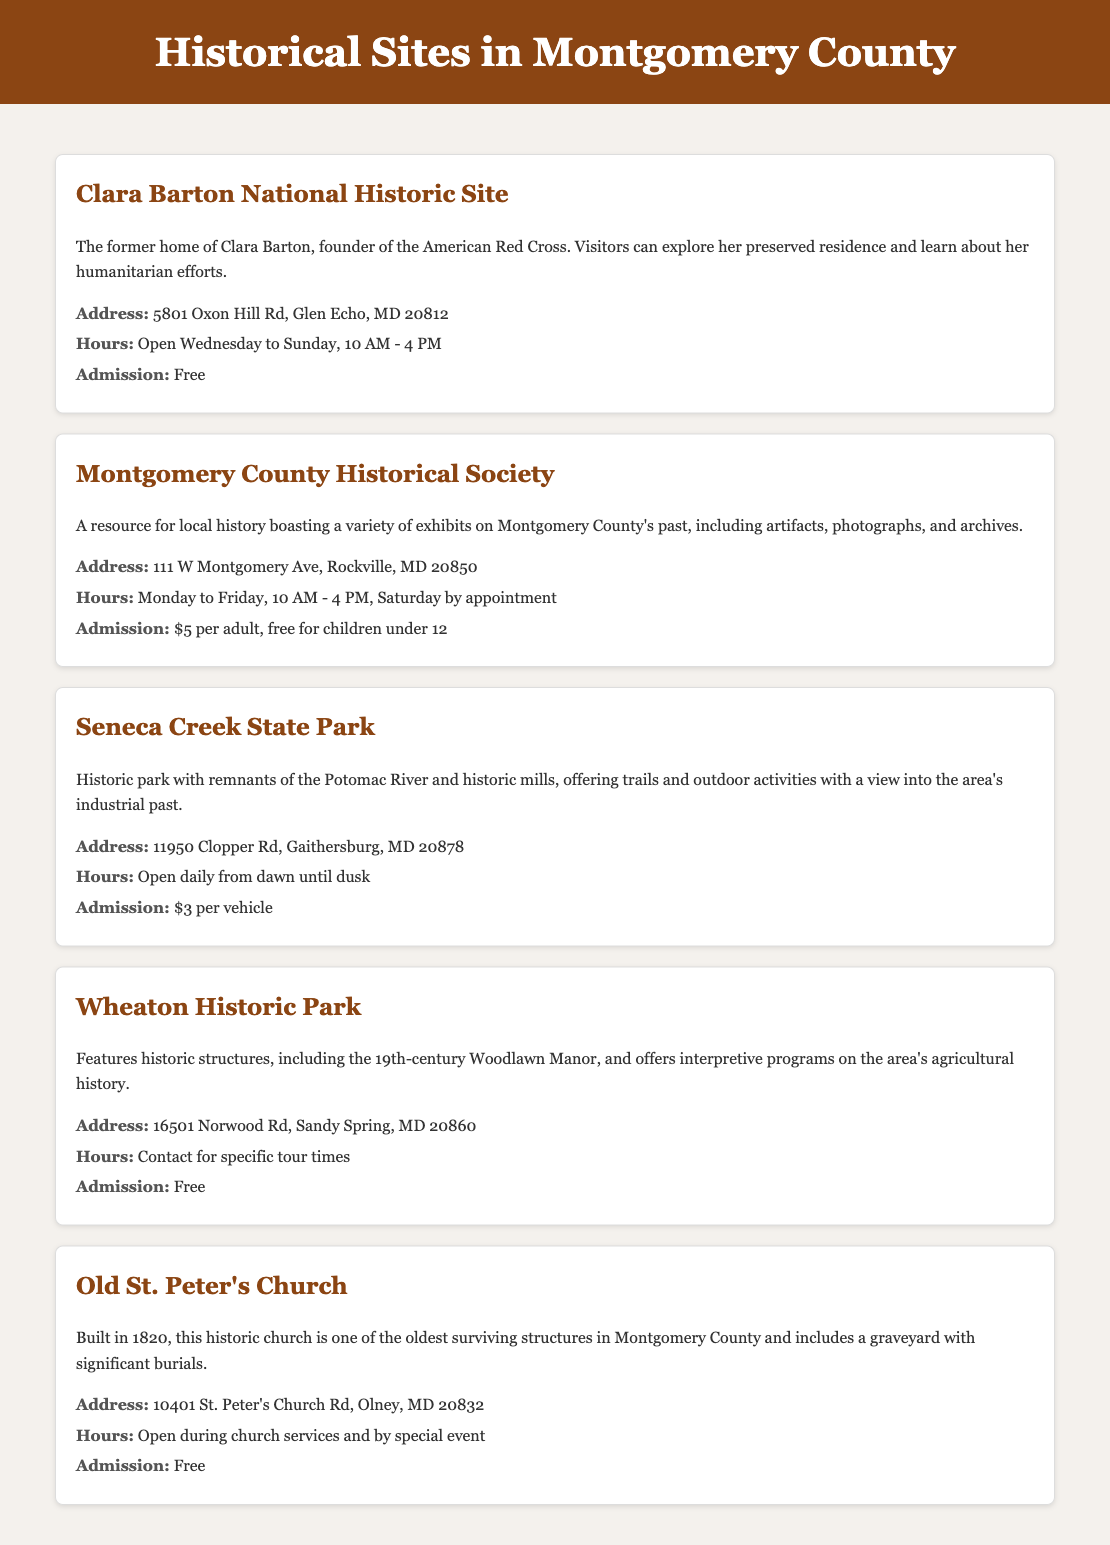What is the address of Clara Barton National Historic Site? The address is directly stated in the document under the site details for Clara Barton National Historic Site.
Answer: 5801 Oxon Hill Rd, Glen Echo, MD 20812 What are the operating hours for the Montgomery County Historical Society? The hours of operation are found in the site details for the Montgomery County Historical Society, presenting a specific timeframe for visits.
Answer: Monday to Friday, 10 AM - 4 PM, Saturday by appointment How much is the admission fee for the Montgomery County Historical Society? The admission fee is explicitly mentioned in the admission section of the Montgomery County Historical Society site card.
Answer: $5 per adult, free for children under 12 Which historic site is open daily from dawn until dusk? This requires connecting the hours of operation with the names of the sites mentioned to find the one that fits the criteria.
Answer: Seneca Creek State Park What type of programs are offered at Wheaton Historic Park? The type of programs is provided in the description of Wheaton Historic Park, highlighting its focus on a specific theme related to local history.
Answer: Interpretive programs on the area's agricultural history What year was Old St. Peter's Church built? The year of construction is directly mentioned in the description of Old St. Peter's Church.
Answer: 1820 